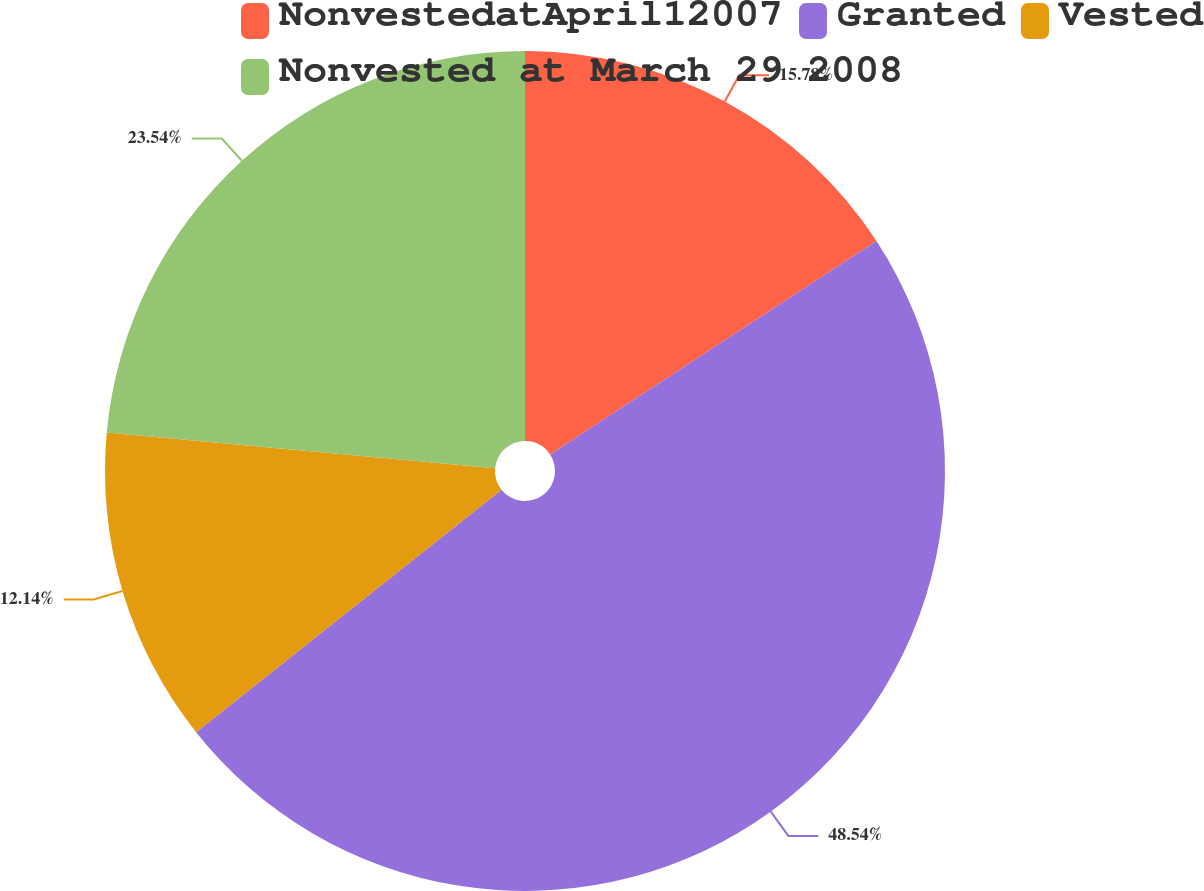<chart> <loc_0><loc_0><loc_500><loc_500><pie_chart><fcel>NonvestedatApril12007<fcel>Granted<fcel>Vested<fcel>Nonvested at March 29 2008<nl><fcel>15.78%<fcel>48.54%<fcel>12.14%<fcel>23.54%<nl></chart> 